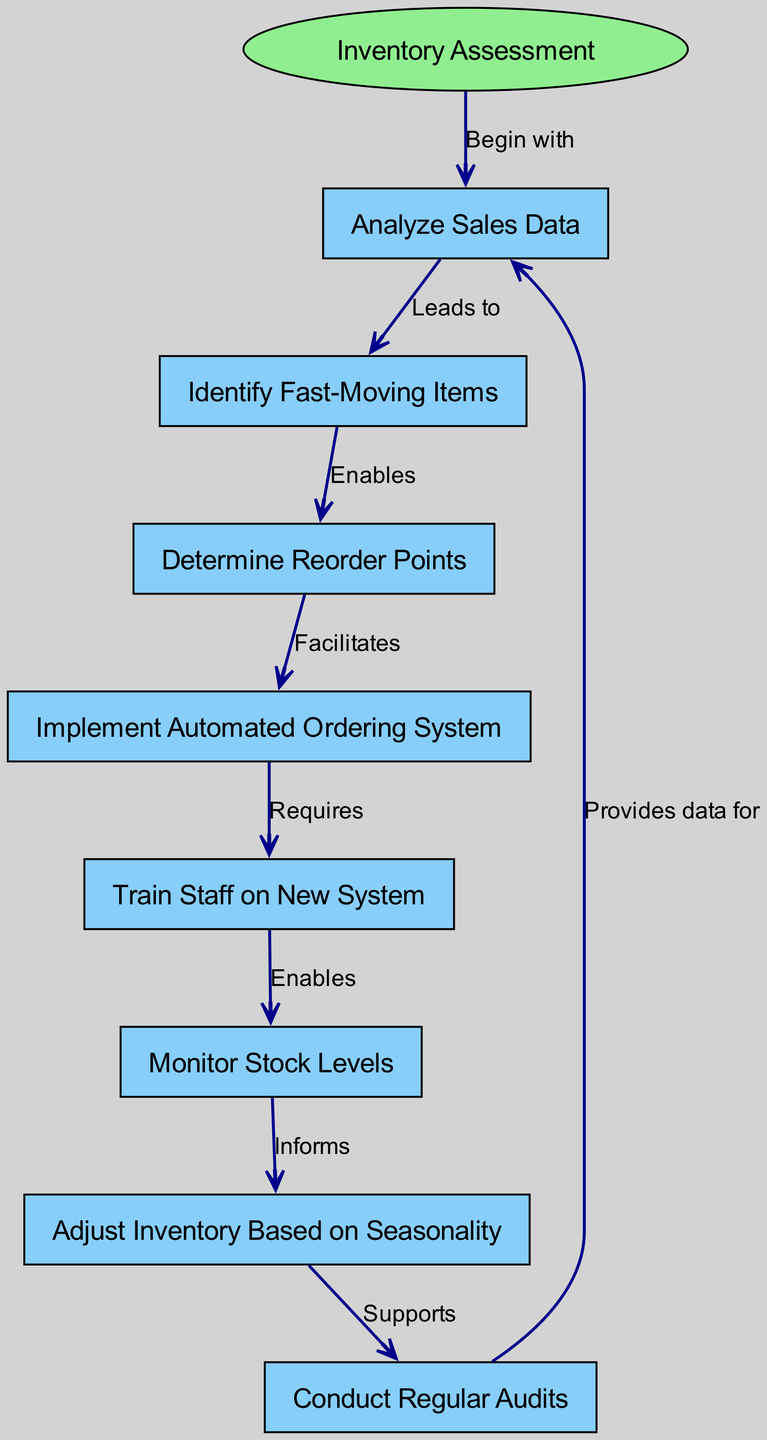What is the starting point of the clinical pathway? The diagram clearly indicates that the starting point is labeled as "Inventory Assessment." This is the initial node where the process begins.
Answer: Inventory Assessment How many nodes are there in the diagram? By reviewing the node section of the diagram, we count a total of eight nodes that depict different stages of the inventory management process.
Answer: Eight What does "Analyze Sales Data" enable? The edge leading from "Analyze Sales Data" to "Identify Fast-Moving Items" indicates that the former action enables the latter. This shows that analyzing sales data is crucial for identifying which items sell quickly.
Answer: Identify Fast-Moving Items What action is required after implementing the automated ordering system? According to the edge from "Implement Automated Ordering System" to "Train Staff on New System," training staff on the new system is required after the automated system is put in place.
Answer: Train Staff on New System Which node supports conducting regular audits? The edge from "Adjust Inventory Based on Seasonality" to "Conduct Regular Audits" confirms that adjusting inventory according to seasonal changes supports the practice of conducting regular audits.
Answer: Conduct Regular Audits What informs the adjustment of inventory based on seasonality? The diagram shows an edge from "Monitor Stock Levels" to "Adjust Inventory Based on Seasonality," meaning that monitoring stock levels provides the necessary information to make seasonal adjustments in inventory.
Answer: Monitor Stock Levels How does the auditing process relate to analyzing sales data? The diagram has a circular relationship where "Conduct Regular Audits" provides data for "Analyze Sales Data," indicating that the audits give feedback that informs future sales data analysis.
Answer: Provides data for Analyze Sales Data What is the relationship between determining reorder points and implementing an automated ordering system? The edge from "Determine Reorder Points" to "Implement Automated Ordering System" signifies that determining the appropriate reorder points facilitates the implementation of the automated system, showing the dependency of the latter on the former.
Answer: Facilitates Implement Automated Ordering System 